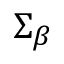Convert formula to latex. <formula><loc_0><loc_0><loc_500><loc_500>\Sigma _ { \beta }</formula> 